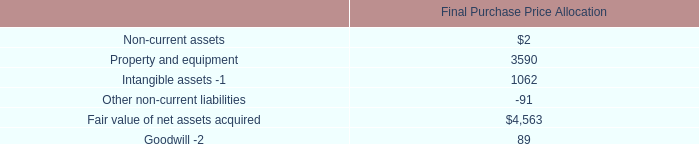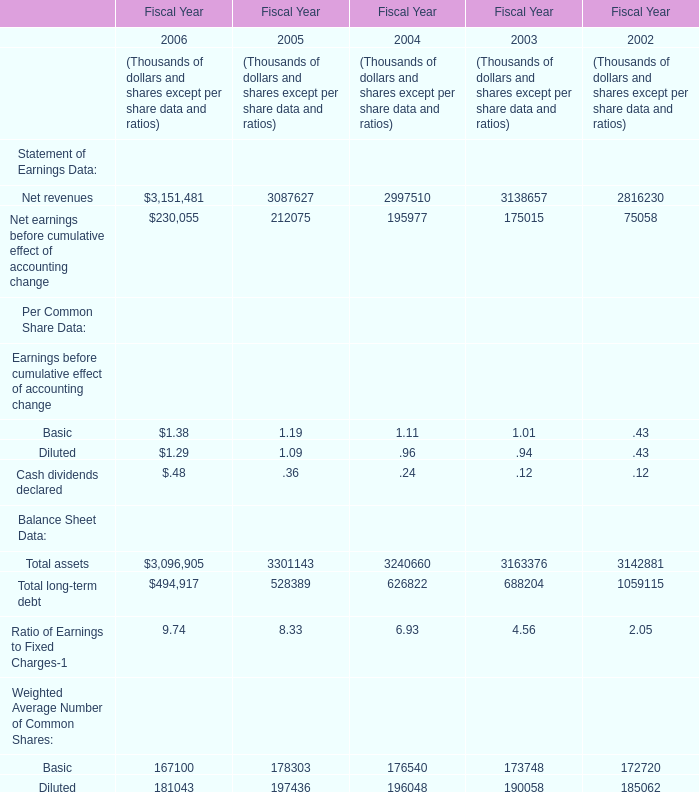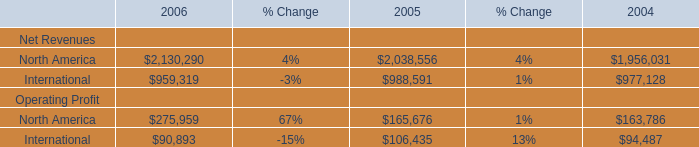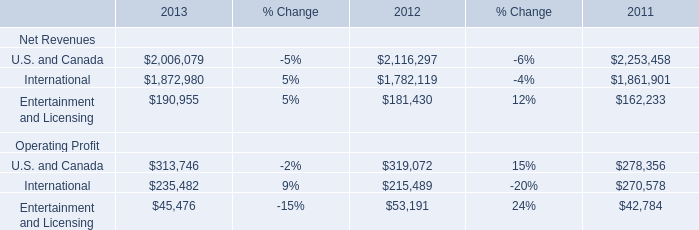What is the sum of Net revenues for Statement of Earnings Data and also North America in 2006? 
Computations: (3151481 + 2130290)
Answer: 5281771.0. 